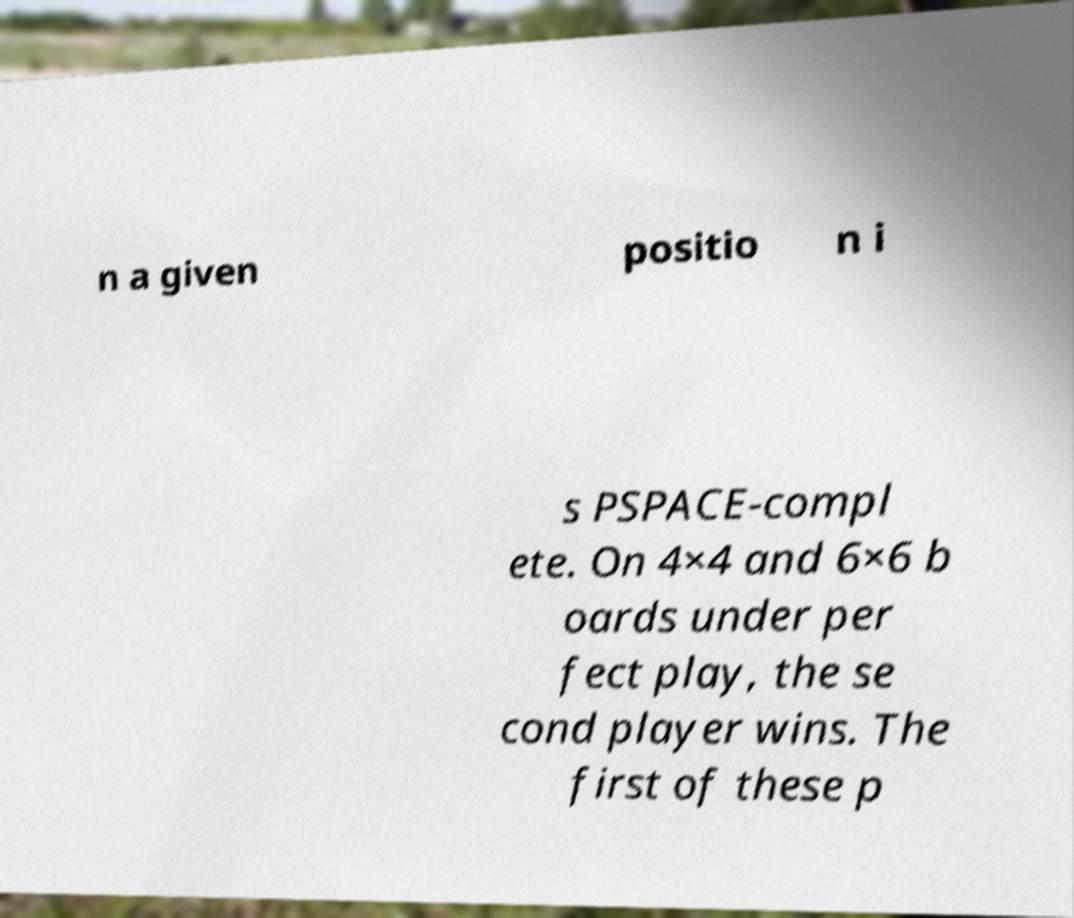I need the written content from this picture converted into text. Can you do that? n a given positio n i s PSPACE-compl ete. On 4×4 and 6×6 b oards under per fect play, the se cond player wins. The first of these p 